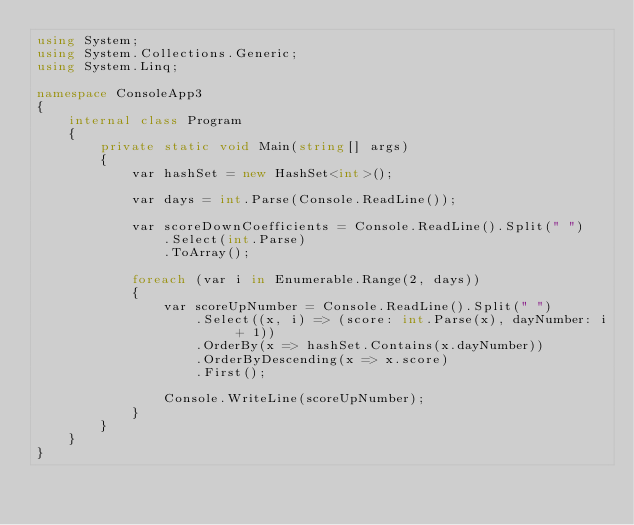Convert code to text. <code><loc_0><loc_0><loc_500><loc_500><_C#_>using System;
using System.Collections.Generic;
using System.Linq;

namespace ConsoleApp3
{
    internal class Program
    {
        private static void Main(string[] args)
        {
            var hashSet = new HashSet<int>();

            var days = int.Parse(Console.ReadLine());

            var scoreDownCoefficients = Console.ReadLine().Split(" ")
                .Select(int.Parse)
                .ToArray();

            foreach (var i in Enumerable.Range(2, days))
            {
                var scoreUpNumber = Console.ReadLine().Split(" ")
                    .Select((x, i) => (score: int.Parse(x), dayNumber: i + 1))
                    .OrderBy(x => hashSet.Contains(x.dayNumber))
                    .OrderByDescending(x => x.score)
                    .First();

                Console.WriteLine(scoreUpNumber);
            }
        }
    }
}
</code> 